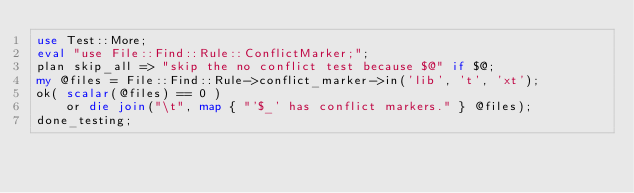<code> <loc_0><loc_0><loc_500><loc_500><_Perl_>use Test::More;
eval "use File::Find::Rule::ConflictMarker;";
plan skip_all => "skip the no conflict test because $@" if $@;
my @files = File::Find::Rule->conflict_marker->in('lib', 't', 'xt');
ok( scalar(@files) == 0 )
    or die join("\t", map { "'$_' has conflict markers." } @files);
done_testing;
</code> 